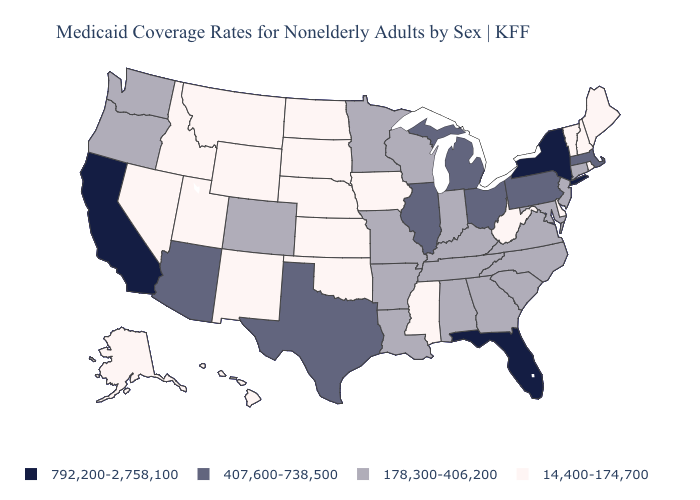Does Vermont have the highest value in the USA?
Answer briefly. No. Name the states that have a value in the range 178,300-406,200?
Write a very short answer. Alabama, Arkansas, Colorado, Connecticut, Georgia, Indiana, Kentucky, Louisiana, Maryland, Minnesota, Missouri, New Jersey, North Carolina, Oregon, South Carolina, Tennessee, Virginia, Washington, Wisconsin. What is the value of Indiana?
Concise answer only. 178,300-406,200. What is the value of Colorado?
Quick response, please. 178,300-406,200. What is the highest value in states that border Ohio?
Write a very short answer. 407,600-738,500. Name the states that have a value in the range 178,300-406,200?
Concise answer only. Alabama, Arkansas, Colorado, Connecticut, Georgia, Indiana, Kentucky, Louisiana, Maryland, Minnesota, Missouri, New Jersey, North Carolina, Oregon, South Carolina, Tennessee, Virginia, Washington, Wisconsin. What is the value of Kansas?
Answer briefly. 14,400-174,700. Among the states that border New Hampshire , does Massachusetts have the highest value?
Be succinct. Yes. What is the lowest value in states that border Tennessee?
Be succinct. 14,400-174,700. What is the value of Wisconsin?
Short answer required. 178,300-406,200. What is the value of Iowa?
Answer briefly. 14,400-174,700. Which states have the highest value in the USA?
Short answer required. California, Florida, New York. What is the value of Maryland?
Give a very brief answer. 178,300-406,200. Among the states that border Virginia , does West Virginia have the lowest value?
Keep it brief. Yes. What is the value of Arizona?
Keep it brief. 407,600-738,500. 